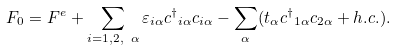<formula> <loc_0><loc_0><loc_500><loc_500>F _ { 0 } = F ^ { e } + \sum _ { i = 1 , 2 , \ \alpha } \varepsilon _ { i \alpha } { { c } ^ { \dag } } _ { i \alpha } c _ { i \alpha } - \sum _ { \alpha } ( t _ { \alpha } { { c } ^ { \dag } } _ { 1 \alpha } c _ { 2 \alpha } + h . c . ) .</formula> 